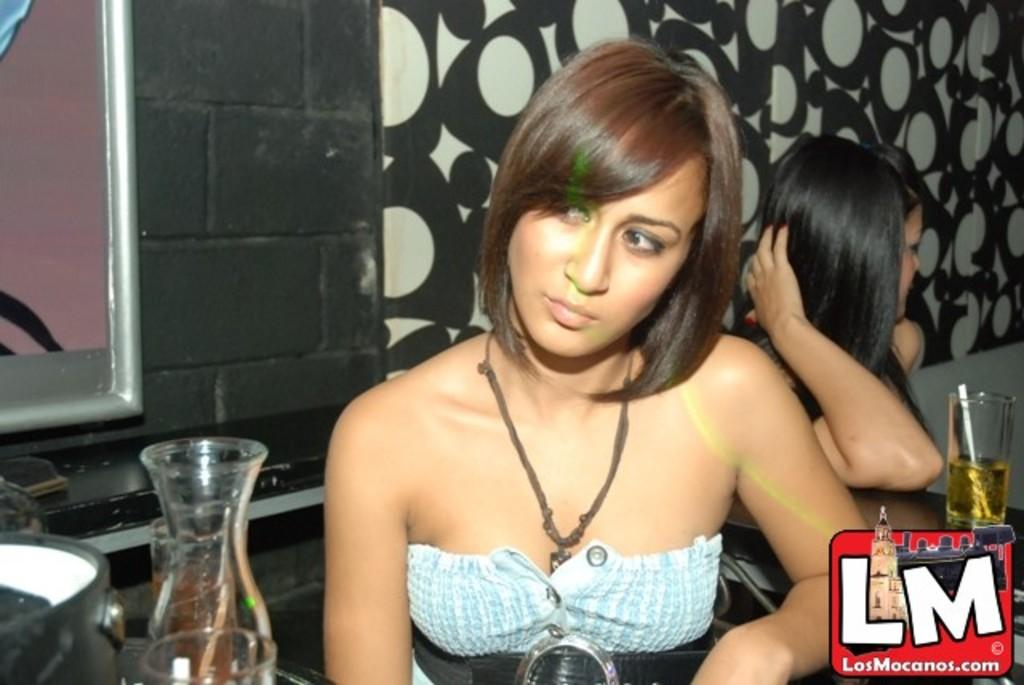Who or what can be seen in the image? There are people in the image. What objects are present in the image? There are glasses, a jug, and a vessel in the image. Where are these objects placed? The objects are placed on tables. What can be seen in the background of the image? There is a wall in the background of the image. What architectural feature is visible on the left side of the image? There is a window on the left side of the image. How many boats are visible in the image? There are no boats present in the image. Is there a cave visible in the image? There is no cave present in the image. 